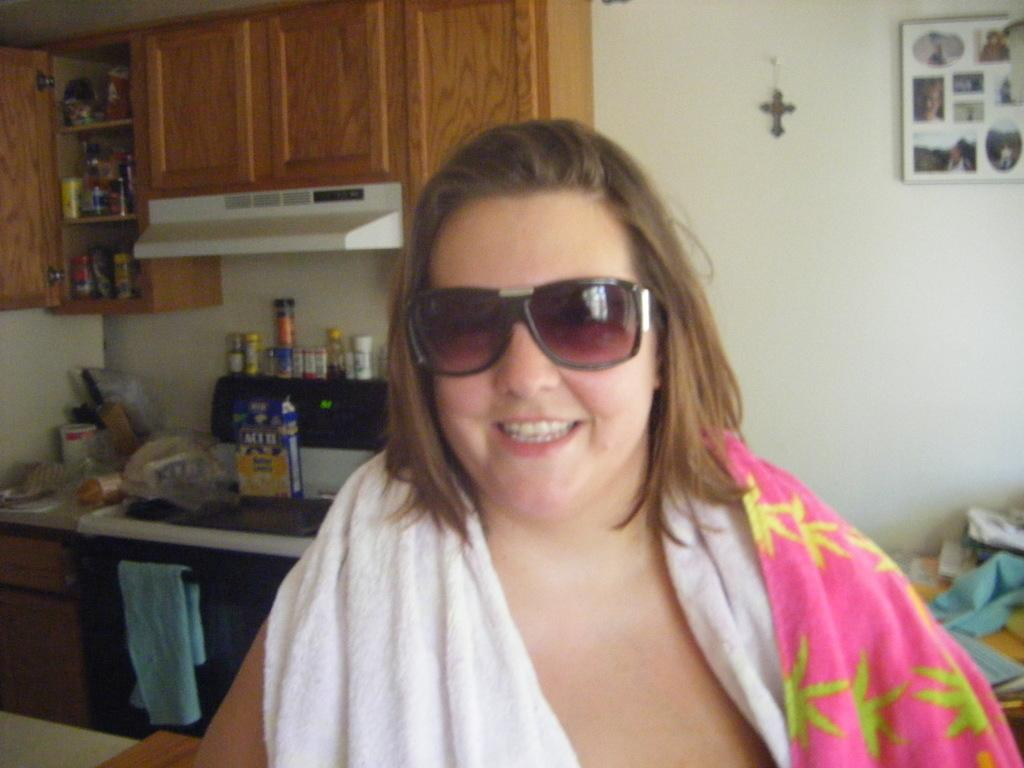Who is present in the image? There is a woman in the image. What is the woman wearing on her face? The woman is wearing goggles. What can be seen in the background of the image? There is a wall, bottles, cupboards, clothes, and a photo frame in the background of the image. Can you describe the other objects in the background? There are other objects in the background of the image, but their specific details are not mentioned in the provided facts. How many men are present in the image? There is no mention of men in the provided facts, so it cannot be determined from the image. What type of light is being used to illuminate the scene in the image? The provided facts do not mention any light source, so it cannot be determined from the image. 